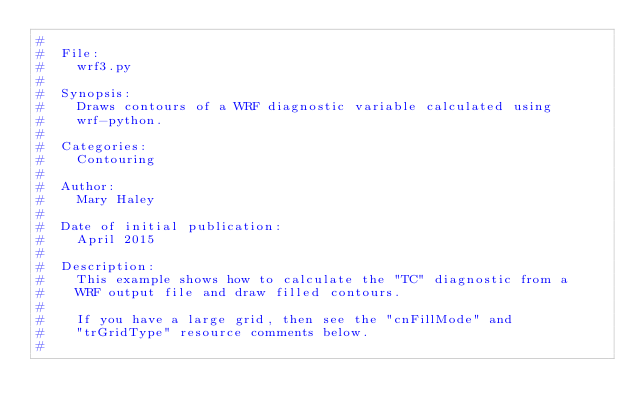<code> <loc_0><loc_0><loc_500><loc_500><_Python_>#
#  File:
#    wrf3.py
#
#  Synopsis:
#    Draws contours of a WRF diagnostic variable calculated using
#    wrf-python.
#
#  Categories:
#    Contouring
#
#  Author:
#    Mary Haley
#  
#  Date of initial publication:
#    April 2015
#
#  Description:
#    This example shows how to calculate the "TC" diagnostic from a 
#    WRF output file and draw filled contours.
#
#    If you have a large grid, then see the "cnFillMode" and
#    "trGridType" resource comments below.
#</code> 